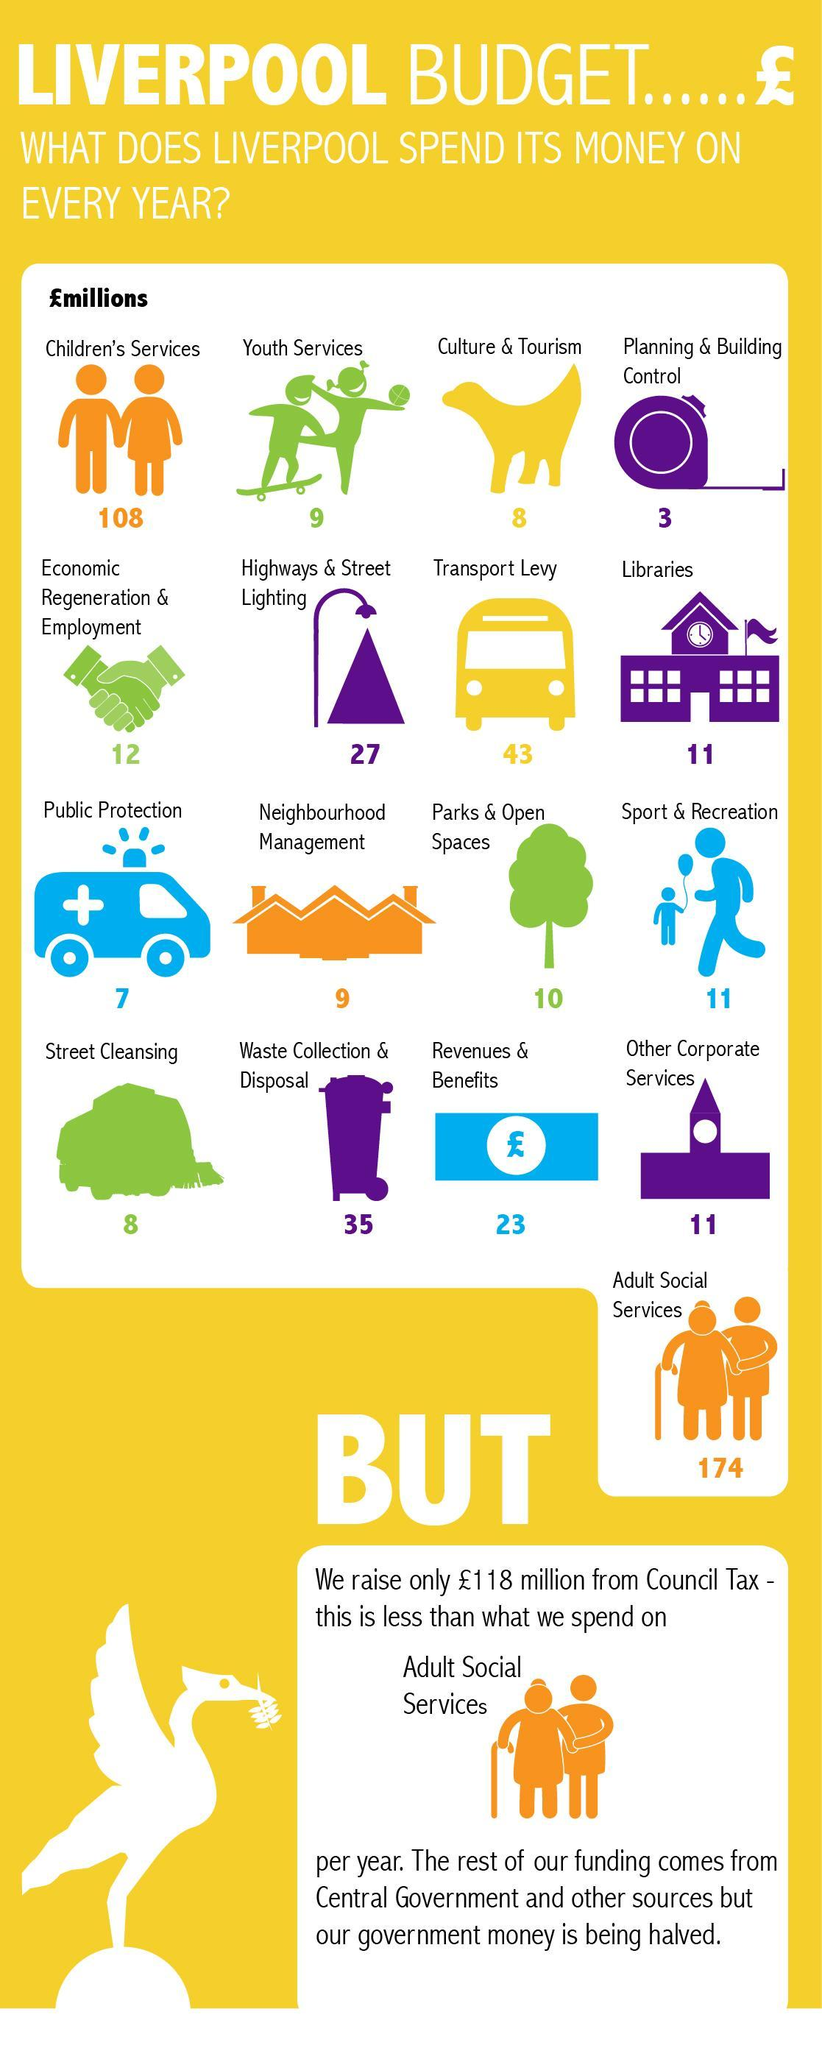How much money is spend by Liverpool on youth services per year in £millions?
Answer the question with a short phrase. 9 Which service has offered the least Liverpool budget every year? Planning & Building Control In which service, Liverpool spend about 108 £millions every year? Children's Services How much money is spend by Liverpool on sports & recreation per year in £millions? 11 How much money is spend by Liverpool on Economic Regeneration & Employment every year in £millions? 12 How much money is spend by Liverpool on culture & tourism every year in £millions? 8 Which service has offered the highest Liverpool budget every year? Adult Social Services How much money is spend by Liverpool on waste collection & disposal per year in £millions? 35 How much money is spend by Liverpool on revenue & benefits per year in £millions? 23 